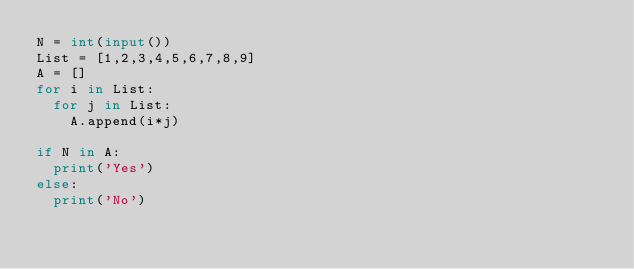<code> <loc_0><loc_0><loc_500><loc_500><_Python_>N = int(input())
List = [1,2,3,4,5,6,7,8,9]
A = []
for i in List:
  for j in List:
    A.append(i*j)
    
if N in A:
  print('Yes')
else:
  print('No')</code> 